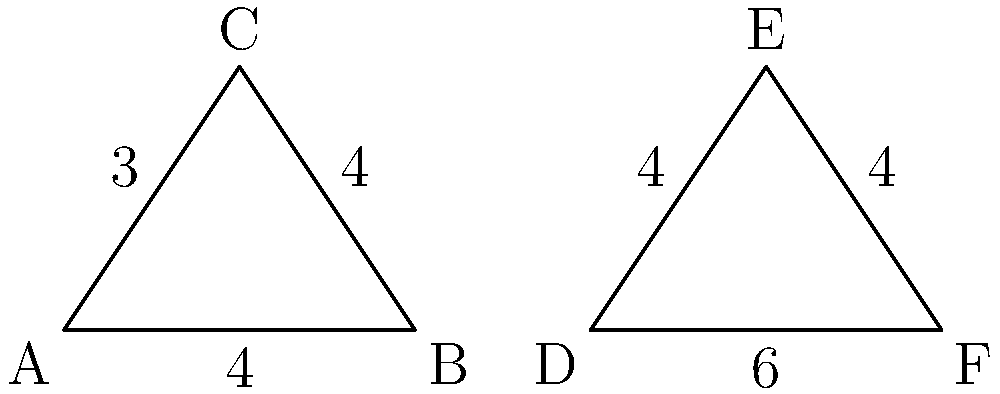Your company is designing a new logo featuring two triangles. Triangle ABC is congruent to triangle DEF. If the base of triangle DEF is 6 units long, what is the length of its height? To solve this problem, we'll use the properties of congruent triangles and the Pythagorean theorem. Let's approach this step-by-step:

1) First, we know that triangle ABC is congruent to triangle DEF. This means all corresponding sides and angles are equal.

2) In triangle ABC, we can see that:
   - The base (AB) is 4 units
   - The height (from C to AB) is 3 units
   - The other two sides are both 4 units

3) Since the triangles are congruent, the ratios of their sides will be the same. Let's call the height of triangle DEF 'h'.

4) We can set up a proportion:
   $$\frac{\text{base of ABC}}{\text{base of DEF}} = \frac{\text{height of ABC}}{\text{height of DEF}}$$

5) Plugging in the values:
   $$\frac{4}{6} = \frac{3}{h}$$

6) Cross multiply:
   $$4h = 18$$

7) Solve for h:
   $$h = \frac{18}{4} = 4.5$$

Therefore, the height of triangle DEF is 4.5 units.
Answer: 4.5 units 